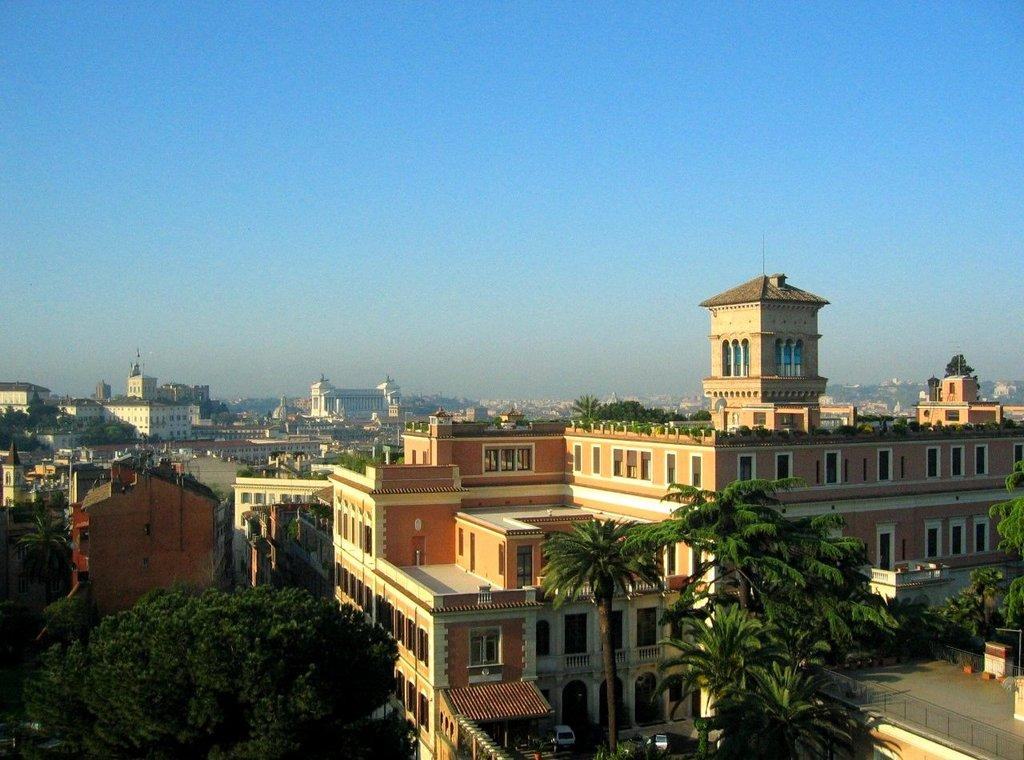What type of perspective is used in the image? The image is a top view. What can be seen in the image from this perspective? There are many buildings and trees in the image. What color is the sky in the background of the image? The sky in the background of the image is blue. How many turkeys are visible in the image? There are no turkeys present in the image. What type of sorting algorithm is being used by the buildings in the image? The image does not depict any sorting algorithms or processes; it simply shows buildings and trees from a top view. 